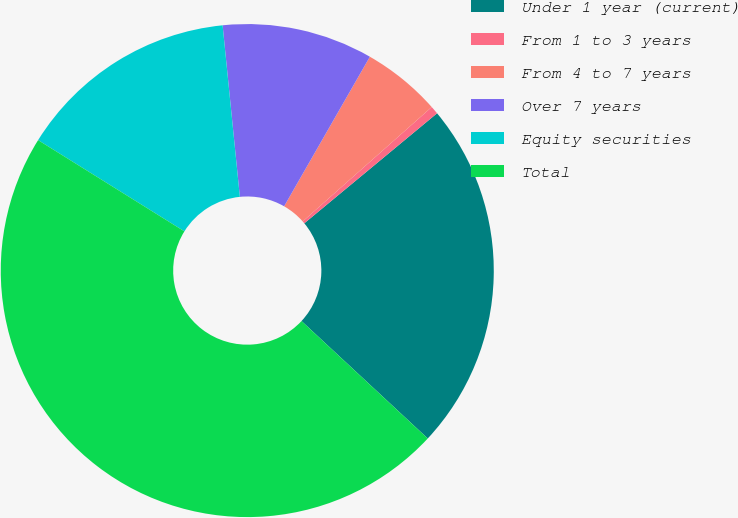Convert chart. <chart><loc_0><loc_0><loc_500><loc_500><pie_chart><fcel>Under 1 year (current)<fcel>From 1 to 3 years<fcel>From 4 to 7 years<fcel>Over 7 years<fcel>Equity securities<fcel>Total<nl><fcel>22.94%<fcel>0.53%<fcel>5.17%<fcel>9.88%<fcel>14.53%<fcel>46.95%<nl></chart> 